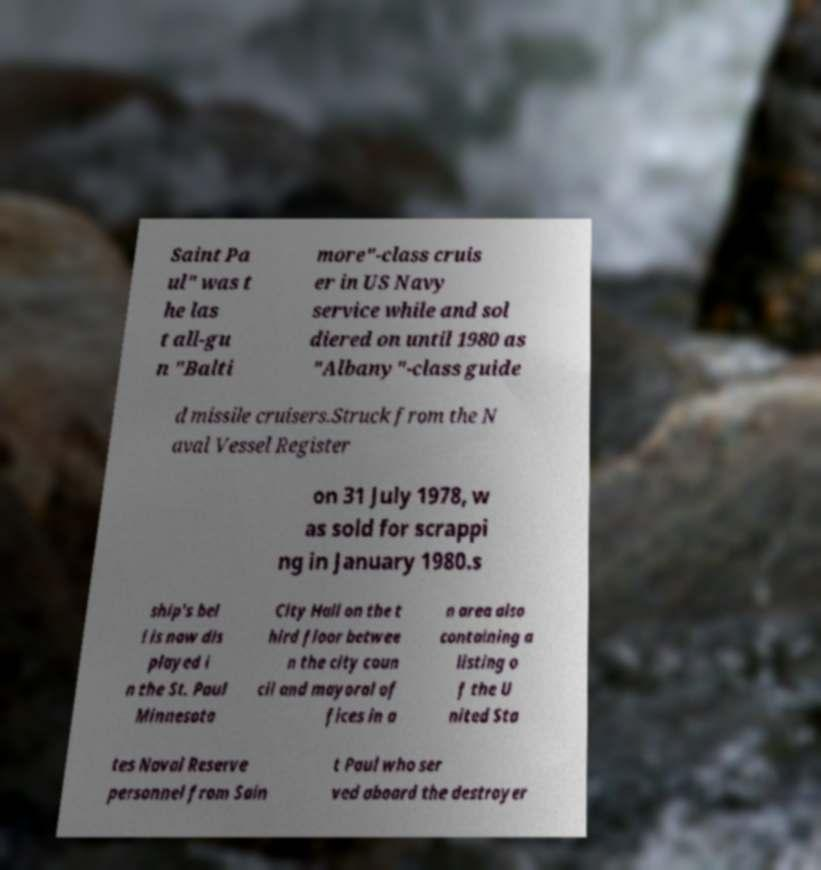I need the written content from this picture converted into text. Can you do that? Saint Pa ul" was t he las t all-gu n "Balti more"-class cruis er in US Navy service while and sol diered on until 1980 as "Albany"-class guide d missile cruisers.Struck from the N aval Vessel Register on 31 July 1978, w as sold for scrappi ng in January 1980.s ship's bel l is now dis played i n the St. Paul Minnesota City Hall on the t hird floor betwee n the city coun cil and mayoral of fices in a n area also containing a listing o f the U nited Sta tes Naval Reserve personnel from Sain t Paul who ser ved aboard the destroyer 